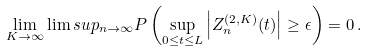Convert formula to latex. <formula><loc_0><loc_0><loc_500><loc_500>\lim _ { K \to \infty } \lim s u p _ { n \to \infty } P \left ( \sup _ { 0 \leq t \leq L } \left | Z _ { n } ^ { ( 2 , K ) } ( t ) \right | \geq \epsilon \right ) = 0 \, .</formula> 